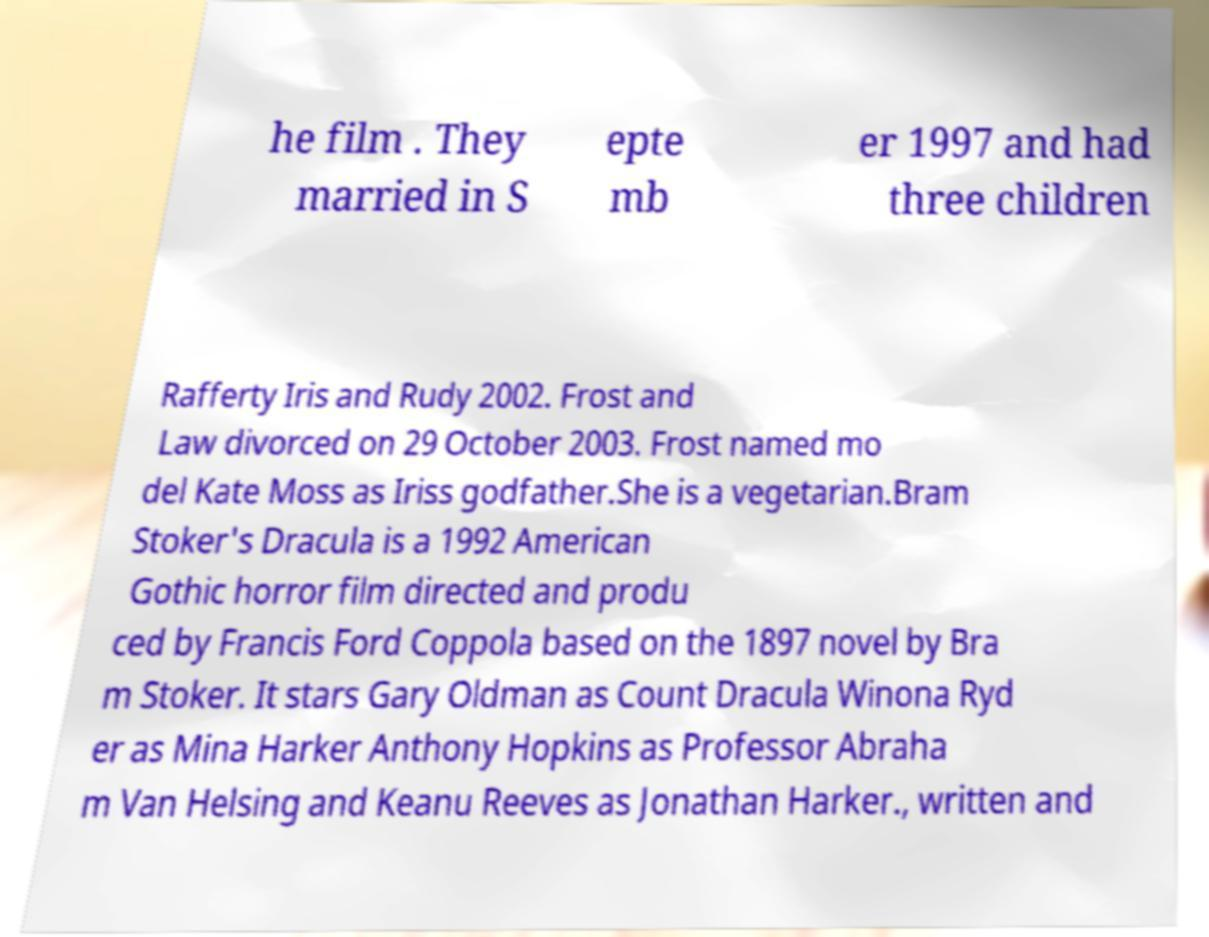Can you accurately transcribe the text from the provided image for me? he film . They married in S epte mb er 1997 and had three children Rafferty Iris and Rudy 2002. Frost and Law divorced on 29 October 2003. Frost named mo del Kate Moss as Iriss godfather.She is a vegetarian.Bram Stoker's Dracula is a 1992 American Gothic horror film directed and produ ced by Francis Ford Coppola based on the 1897 novel by Bra m Stoker. It stars Gary Oldman as Count Dracula Winona Ryd er as Mina Harker Anthony Hopkins as Professor Abraha m Van Helsing and Keanu Reeves as Jonathan Harker., written and 